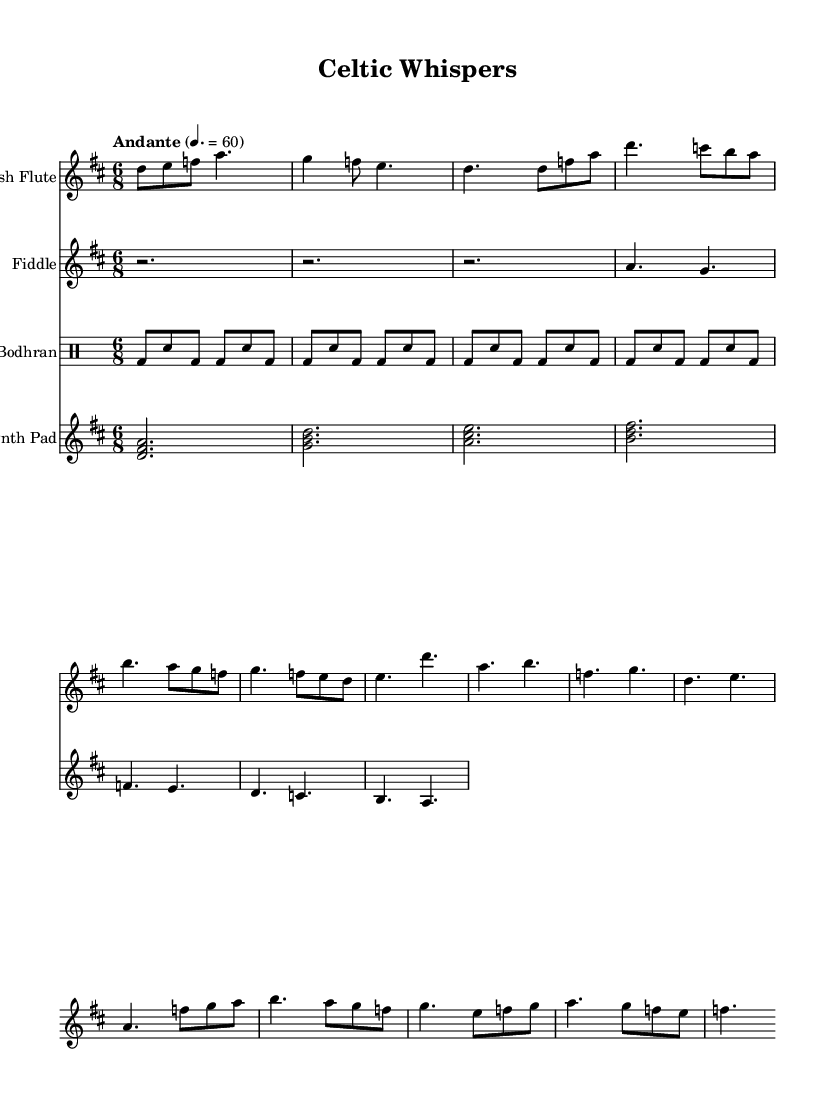What is the key signature of this music? The key signature is D major, which has two sharps (F# and C#). It can be identified by looking at the key signature indicated at the beginning of the score.
Answer: D major What is the time signature of this piece? The time signature is 6/8, which indicates that there are six eighth notes per measure. This can be seen at the beginning of the score, right after the key signature.
Answer: 6/8 What is the tempo marking of this piece? The tempo marking is "Andante," which suggests a moderately slow pace. This is stated at the beginning of the score above the tempo indication, specifying the intended speed.
Answer: Andante How many measures are in the flute part? The flute part contains an intro, verse, chorus, and bridge sections, totaling 16 measures. By visually counting the measures in the flute section from start to end, we find this total.
Answer: 16 Which instrument is primarily featured in the verse? The primary instrument featured in the verse is the flute. In the sheet music, the flute plays the main melody during the verse section, whereas the fiddle primarily plays simplified backing lines.
Answer: Flute What is the rhythmic pattern played by the bodhran? The rhythmic pattern played by the bodhran consists of a specific sequence of beats that includes bass (bd) and snare (sn) rhythms. This pattern can be recognized by looking at the notated drum part.
Answer: bd8 sn bd bd sn bd What type of progression is used in the synth part? The synth part is built around a simplified chord progression, featuring major chords in a sequence. These can be observed in the stacked note format on the staff, which designates the harmonic underpinning of the piece.
Answer: Major chords 